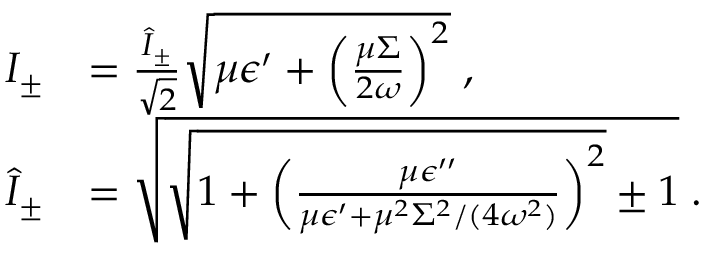Convert formula to latex. <formula><loc_0><loc_0><loc_500><loc_500>\begin{array} { r l } { I _ { \pm } } & { = \frac { \hat { I } _ { \pm } } { \sqrt { 2 } } \sqrt { \mu \epsilon ^ { \prime } + \left ( \frac { \mu \Sigma } { 2 \omega } \right ) ^ { 2 } } \, , } \\ { \hat { I } _ { \pm } } & { = \sqrt { \sqrt { 1 + \left ( \frac { \mu \epsilon ^ { \prime \prime } } { \mu \epsilon ^ { \prime } + \mu ^ { 2 } \Sigma ^ { 2 } / ( 4 \omega ^ { 2 } ) } \right ) ^ { 2 } } \pm 1 } \, . } \end{array}</formula> 